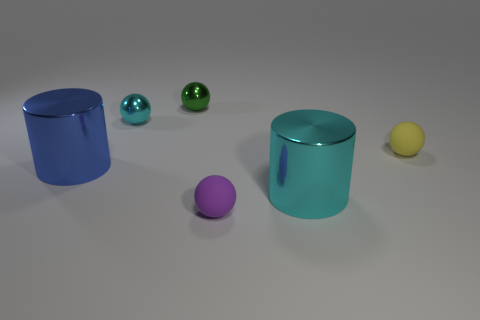Subtract all tiny cyan metal balls. How many balls are left? 3 Add 2 small matte objects. How many objects exist? 8 Subtract all yellow balls. How many balls are left? 3 Subtract 2 balls. How many balls are left? 2 Subtract all big green matte objects. Subtract all tiny rubber balls. How many objects are left? 4 Add 2 tiny matte things. How many tiny matte things are left? 4 Add 2 small purple rubber things. How many small purple rubber things exist? 3 Subtract 0 gray balls. How many objects are left? 6 Subtract all cylinders. How many objects are left? 4 Subtract all brown cylinders. Subtract all yellow spheres. How many cylinders are left? 2 